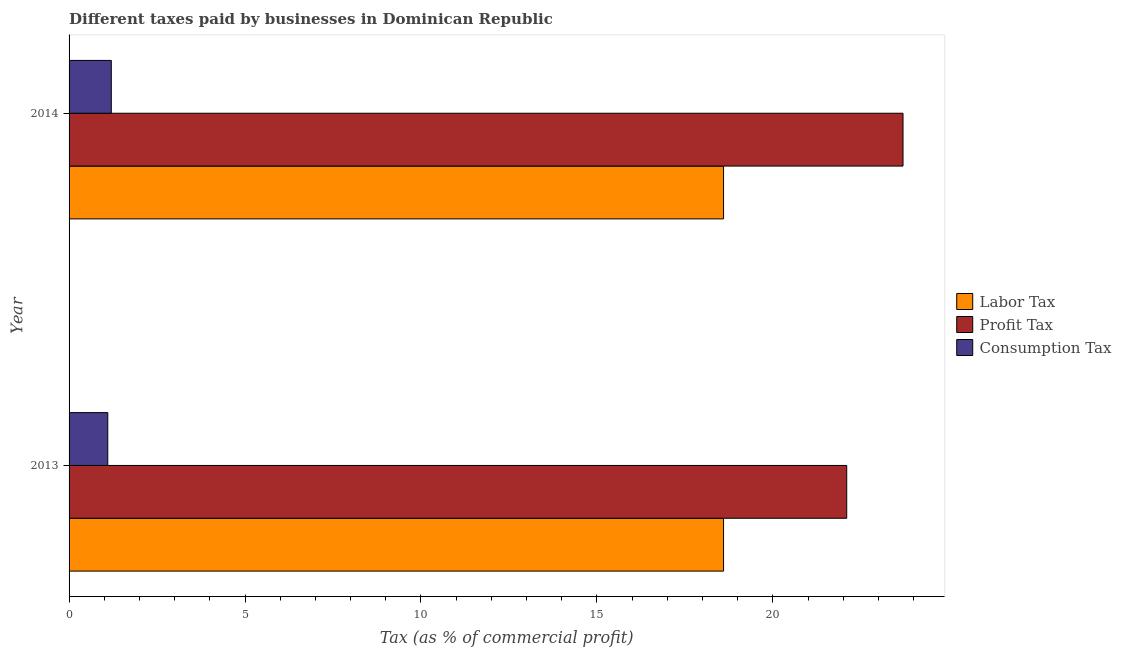How many bars are there on the 2nd tick from the top?
Provide a succinct answer. 3. What is the label of the 1st group of bars from the top?
Give a very brief answer. 2014. What is the percentage of profit tax in 2013?
Make the answer very short. 22.1. In which year was the percentage of profit tax minimum?
Provide a succinct answer. 2013. What is the total percentage of labor tax in the graph?
Provide a short and direct response. 37.2. What is the difference between the percentage of profit tax in 2013 and the percentage of consumption tax in 2014?
Your answer should be compact. 20.9. What is the average percentage of labor tax per year?
Offer a terse response. 18.6. In the year 2014, what is the difference between the percentage of consumption tax and percentage of profit tax?
Give a very brief answer. -22.5. What is the ratio of the percentage of profit tax in 2013 to that in 2014?
Your answer should be compact. 0.93. In how many years, is the percentage of consumption tax greater than the average percentage of consumption tax taken over all years?
Provide a short and direct response. 1. What does the 2nd bar from the top in 2013 represents?
Offer a terse response. Profit Tax. What does the 2nd bar from the bottom in 2014 represents?
Provide a succinct answer. Profit Tax. How many bars are there?
Offer a very short reply. 6. Are all the bars in the graph horizontal?
Offer a very short reply. Yes. What is the difference between two consecutive major ticks on the X-axis?
Your answer should be compact. 5. Are the values on the major ticks of X-axis written in scientific E-notation?
Provide a succinct answer. No. Does the graph contain any zero values?
Provide a succinct answer. No. How many legend labels are there?
Provide a short and direct response. 3. How are the legend labels stacked?
Make the answer very short. Vertical. What is the title of the graph?
Offer a terse response. Different taxes paid by businesses in Dominican Republic. Does "Ages 65 and above" appear as one of the legend labels in the graph?
Offer a very short reply. No. What is the label or title of the X-axis?
Make the answer very short. Tax (as % of commercial profit). What is the Tax (as % of commercial profit) of Labor Tax in 2013?
Keep it short and to the point. 18.6. What is the Tax (as % of commercial profit) of Profit Tax in 2013?
Offer a terse response. 22.1. What is the Tax (as % of commercial profit) in Consumption Tax in 2013?
Ensure brevity in your answer.  1.1. What is the Tax (as % of commercial profit) in Labor Tax in 2014?
Ensure brevity in your answer.  18.6. What is the Tax (as % of commercial profit) of Profit Tax in 2014?
Offer a very short reply. 23.7. What is the Tax (as % of commercial profit) of Consumption Tax in 2014?
Keep it short and to the point. 1.2. Across all years, what is the maximum Tax (as % of commercial profit) in Profit Tax?
Offer a very short reply. 23.7. Across all years, what is the maximum Tax (as % of commercial profit) of Consumption Tax?
Your answer should be very brief. 1.2. Across all years, what is the minimum Tax (as % of commercial profit) of Profit Tax?
Offer a very short reply. 22.1. What is the total Tax (as % of commercial profit) in Labor Tax in the graph?
Keep it short and to the point. 37.2. What is the total Tax (as % of commercial profit) of Profit Tax in the graph?
Your response must be concise. 45.8. What is the difference between the Tax (as % of commercial profit) of Profit Tax in 2013 and that in 2014?
Make the answer very short. -1.6. What is the difference between the Tax (as % of commercial profit) of Consumption Tax in 2013 and that in 2014?
Your answer should be compact. -0.1. What is the difference between the Tax (as % of commercial profit) in Labor Tax in 2013 and the Tax (as % of commercial profit) in Consumption Tax in 2014?
Keep it short and to the point. 17.4. What is the difference between the Tax (as % of commercial profit) in Profit Tax in 2013 and the Tax (as % of commercial profit) in Consumption Tax in 2014?
Keep it short and to the point. 20.9. What is the average Tax (as % of commercial profit) of Labor Tax per year?
Provide a short and direct response. 18.6. What is the average Tax (as % of commercial profit) in Profit Tax per year?
Keep it short and to the point. 22.9. What is the average Tax (as % of commercial profit) of Consumption Tax per year?
Your answer should be compact. 1.15. In the year 2013, what is the difference between the Tax (as % of commercial profit) in Profit Tax and Tax (as % of commercial profit) in Consumption Tax?
Give a very brief answer. 21. In the year 2014, what is the difference between the Tax (as % of commercial profit) of Labor Tax and Tax (as % of commercial profit) of Consumption Tax?
Offer a terse response. 17.4. In the year 2014, what is the difference between the Tax (as % of commercial profit) of Profit Tax and Tax (as % of commercial profit) of Consumption Tax?
Your response must be concise. 22.5. What is the ratio of the Tax (as % of commercial profit) of Labor Tax in 2013 to that in 2014?
Your response must be concise. 1. What is the ratio of the Tax (as % of commercial profit) in Profit Tax in 2013 to that in 2014?
Keep it short and to the point. 0.93. What is the ratio of the Tax (as % of commercial profit) in Consumption Tax in 2013 to that in 2014?
Keep it short and to the point. 0.92. What is the difference between the highest and the second highest Tax (as % of commercial profit) in Profit Tax?
Make the answer very short. 1.6. What is the difference between the highest and the second highest Tax (as % of commercial profit) of Consumption Tax?
Your response must be concise. 0.1. What is the difference between the highest and the lowest Tax (as % of commercial profit) of Profit Tax?
Keep it short and to the point. 1.6. What is the difference between the highest and the lowest Tax (as % of commercial profit) of Consumption Tax?
Your answer should be very brief. 0.1. 